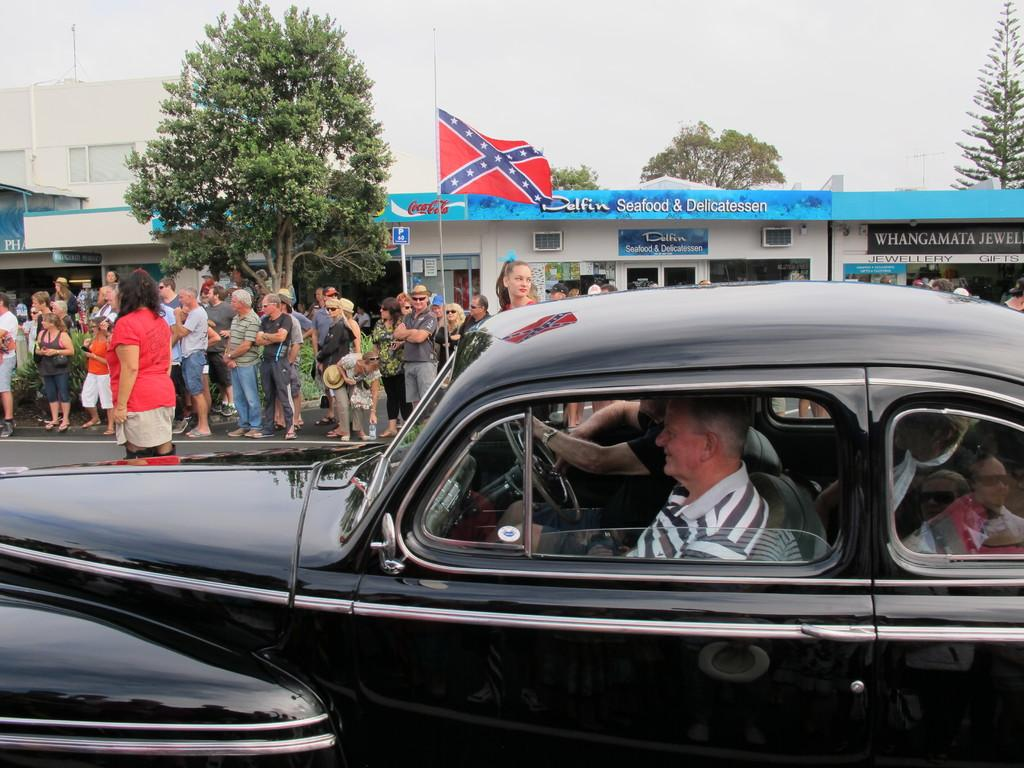How many people are in the image? There is a group of people in the image. What are the people in the image doing? Some people are standing, while others are seated in a car. What can be seen in the background of the image? There are trees, buildings, and a flag in the background of the image. What type of rifle can be seen in the hands of the people in the image? There is no rifle present in the image; the people are either standing or seated in a car. 